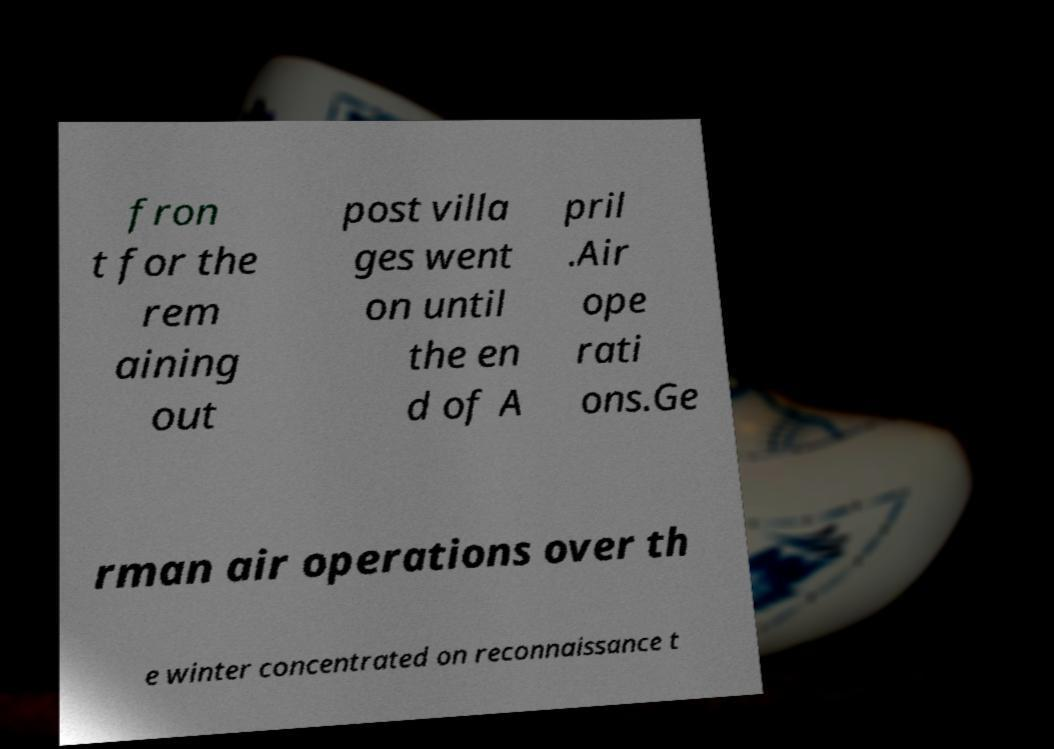I need the written content from this picture converted into text. Can you do that? fron t for the rem aining out post villa ges went on until the en d of A pril .Air ope rati ons.Ge rman air operations over th e winter concentrated on reconnaissance t 